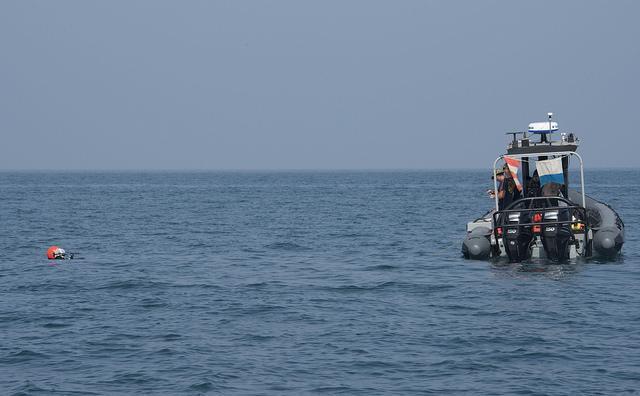How many birds in the shot?
Give a very brief answer. 0. 